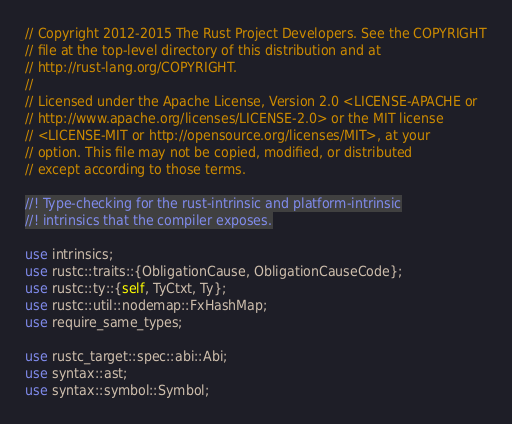<code> <loc_0><loc_0><loc_500><loc_500><_Rust_>// Copyright 2012-2015 The Rust Project Developers. See the COPYRIGHT
// file at the top-level directory of this distribution and at
// http://rust-lang.org/COPYRIGHT.
//
// Licensed under the Apache License, Version 2.0 <LICENSE-APACHE or
// http://www.apache.org/licenses/LICENSE-2.0> or the MIT license
// <LICENSE-MIT or http://opensource.org/licenses/MIT>, at your
// option. This file may not be copied, modified, or distributed
// except according to those terms.

//! Type-checking for the rust-intrinsic and platform-intrinsic
//! intrinsics that the compiler exposes.

use intrinsics;
use rustc::traits::{ObligationCause, ObligationCauseCode};
use rustc::ty::{self, TyCtxt, Ty};
use rustc::util::nodemap::FxHashMap;
use require_same_types;

use rustc_target::spec::abi::Abi;
use syntax::ast;
use syntax::symbol::Symbol;</code> 